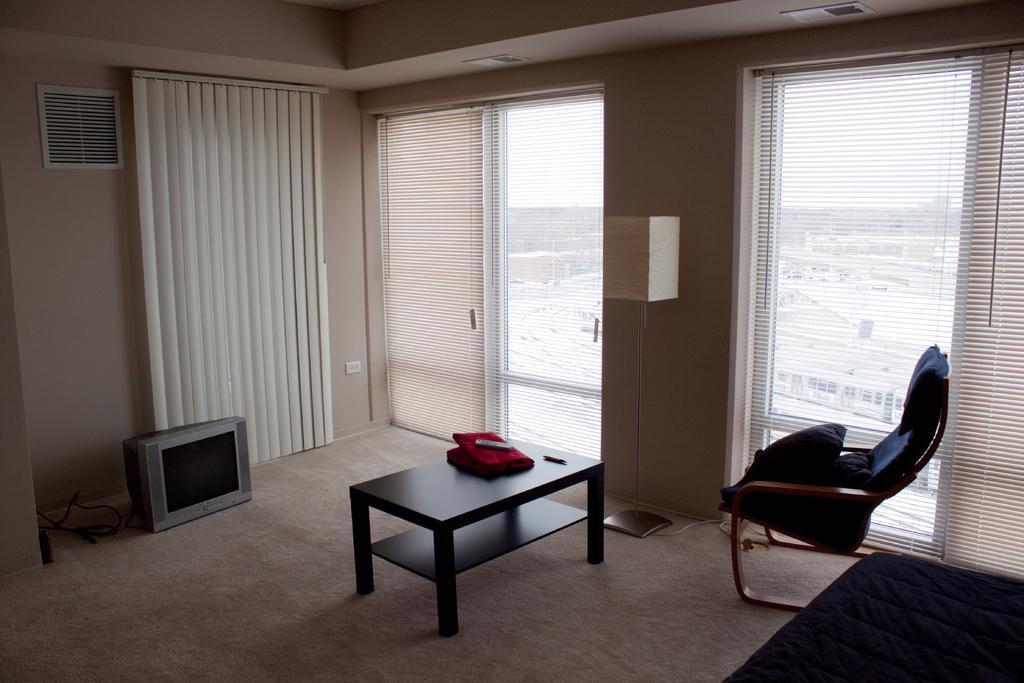In one or two sentences, can you explain what this image depicts? In this picture you will see a room in room you will find one TV,Table ,Chair. 